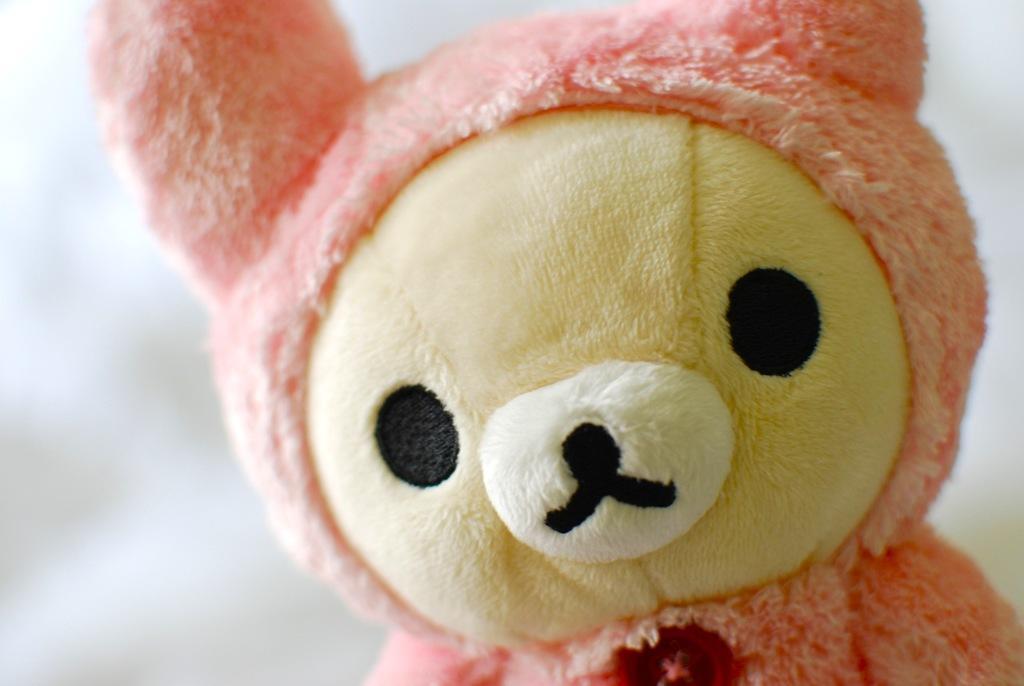Could you give a brief overview of what you see in this image? In this image I can see a soft toy and there is a white background. 